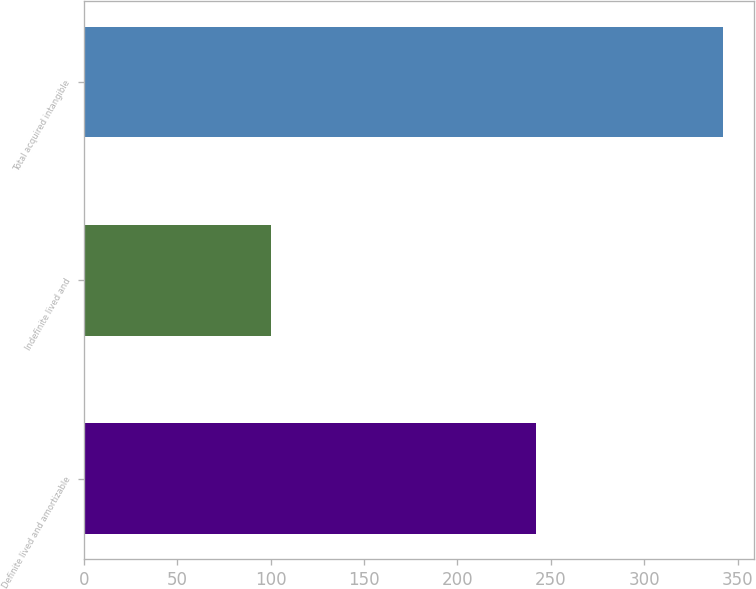Convert chart. <chart><loc_0><loc_0><loc_500><loc_500><bar_chart><fcel>Definite lived and amortizable<fcel>Indefinite lived and<fcel>Total acquired intangible<nl><fcel>242<fcel>100<fcel>342<nl></chart> 